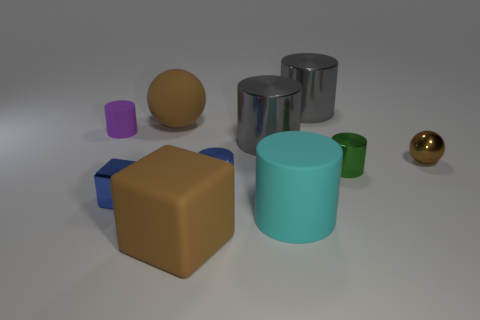What materials do the objects in the image seem to be made of? The objects in the image appear to be made of different materials. The cylinders and the sphere have reflective surfaces suggesting they could be made of metal. The cube and the small rectangular objects seem to have a matte finish, which might indicate plastic or rubber materials. 